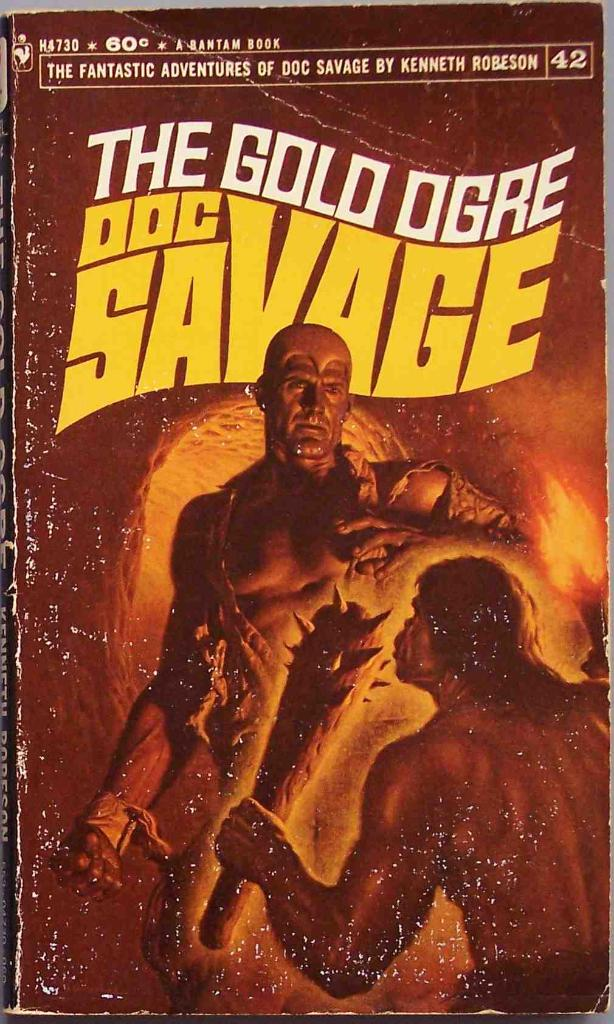Explain the visual content of the image in great detail. The image presents a richly colored cover of 'The Gold Ogre' by Kenneth Robeson, priced at 60 cents, indicating its vintage status possibly from the mid-20th century. The title is emblazoned in bold, yellow letters at the top, with a series tagline 'The Fantastic Adventures of Doc Savage' placed just beneath it. The cover art, evocative and packed with action, features Doc Savage in a tense encounter within a dimly lit cave, where he confronts a towering, menacing ogre. The intense expressions and dynamic poses of the characters add a dramatic flair. The cover is moderately worn, conveying its usage and age, with distinct crease marks and some scuffing noticeable on the edges. The aesthetic combines elements of pulp fiction art, characterized by its bold, dramatic portrayals and a focus on adventure and excitement. 